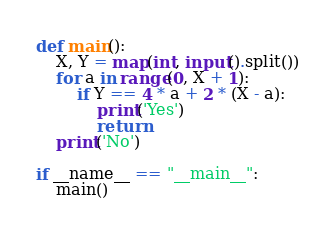<code> <loc_0><loc_0><loc_500><loc_500><_Python_>
def main():
    X, Y = map(int, input().split())
    for a in range(0, X + 1):
        if Y == 4 * a + 2 * (X - a):
            print('Yes')
            return
    print('No')

if __name__ == "__main__":
    main()
</code> 